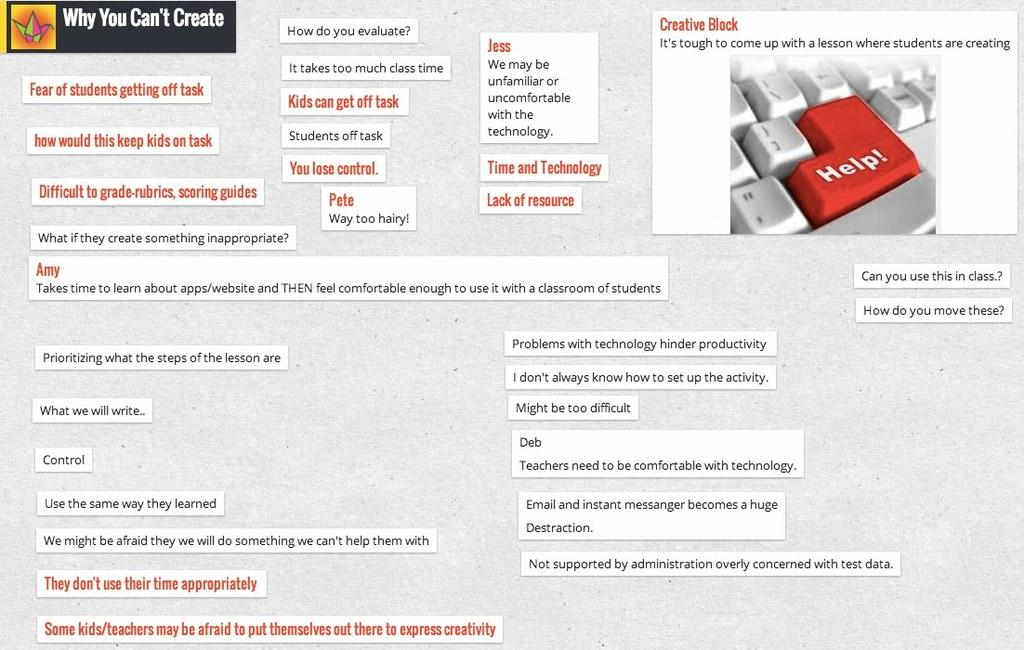Provide a one-sentence caption for the provided image. a poster for "Why you create" with a red key reading Help. 